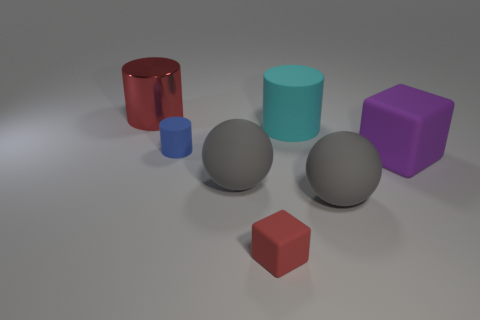Subtract all red balls. Subtract all blue cylinders. How many balls are left? 2 Subtract all green cylinders. How many gray blocks are left? 0 Add 2 purples. How many objects exist? 0 Subtract all big objects. Subtract all tiny matte cylinders. How many objects are left? 1 Add 7 red metal cylinders. How many red metal cylinders are left? 8 Add 7 yellow metallic balls. How many yellow metallic balls exist? 7 Add 3 rubber objects. How many objects exist? 10 Subtract all red cylinders. How many cylinders are left? 2 Subtract all large red cylinders. How many cylinders are left? 2 Subtract 0 yellow cylinders. How many objects are left? 7 